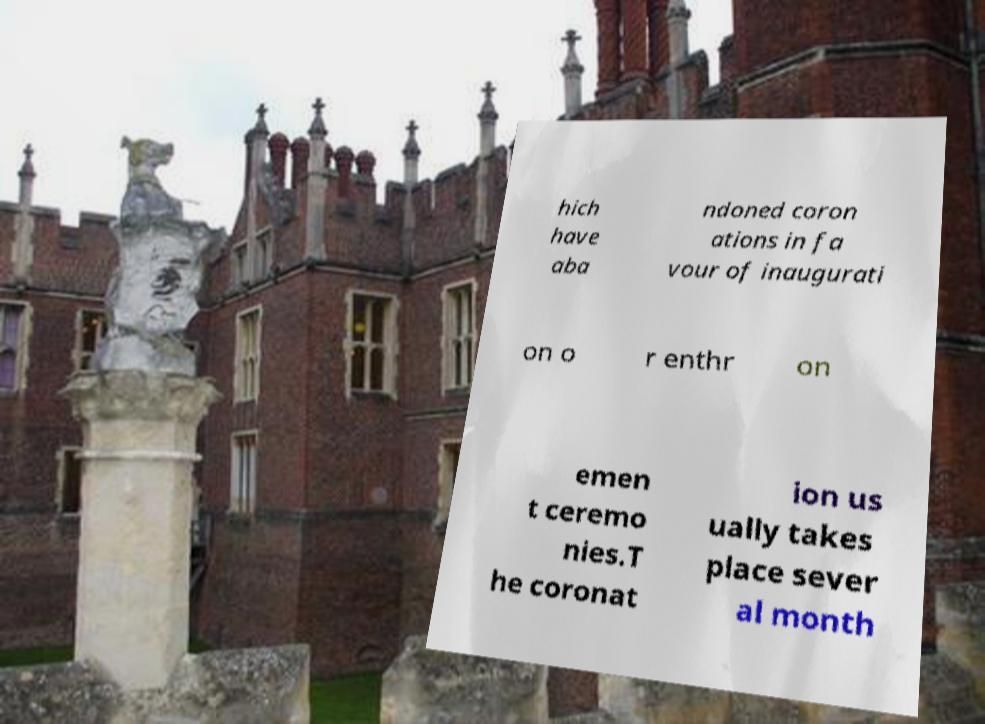Could you extract and type out the text from this image? hich have aba ndoned coron ations in fa vour of inaugurati on o r enthr on emen t ceremo nies.T he coronat ion us ually takes place sever al month 